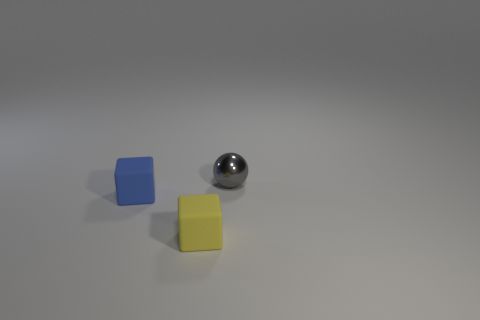Add 1 tiny green blocks. How many objects exist? 4 Subtract all blocks. How many objects are left? 1 Subtract all blue cubes. How many cubes are left? 1 Subtract all red cylinders. How many blue cubes are left? 1 Subtract all big blue matte spheres. Subtract all small yellow rubber cubes. How many objects are left? 2 Add 2 blue things. How many blue things are left? 3 Add 3 tiny gray balls. How many tiny gray balls exist? 4 Subtract 0 gray cylinders. How many objects are left? 3 Subtract all purple cubes. Subtract all gray balls. How many cubes are left? 2 